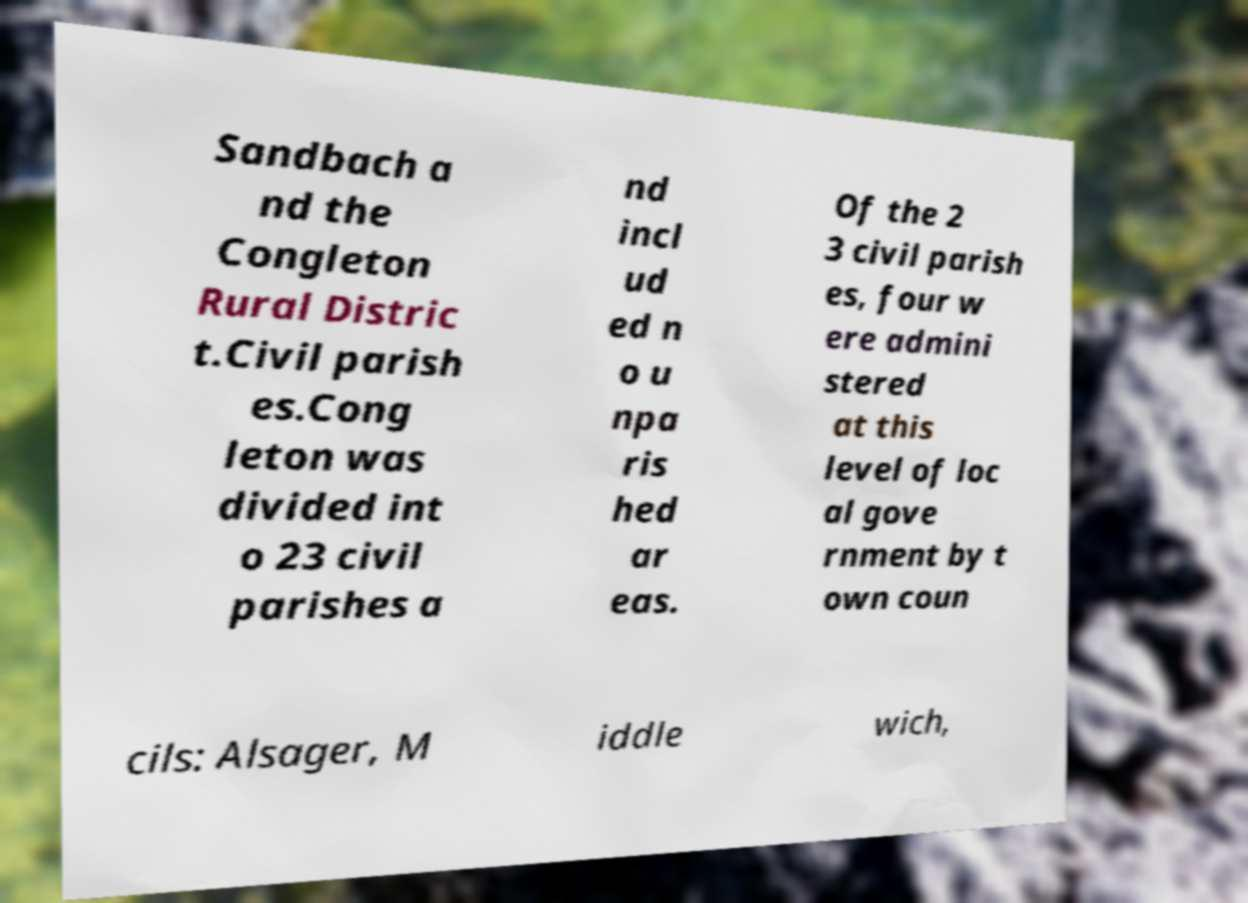Can you read and provide the text displayed in the image?This photo seems to have some interesting text. Can you extract and type it out for me? Sandbach a nd the Congleton Rural Distric t.Civil parish es.Cong leton was divided int o 23 civil parishes a nd incl ud ed n o u npa ris hed ar eas. Of the 2 3 civil parish es, four w ere admini stered at this level of loc al gove rnment by t own coun cils: Alsager, M iddle wich, 